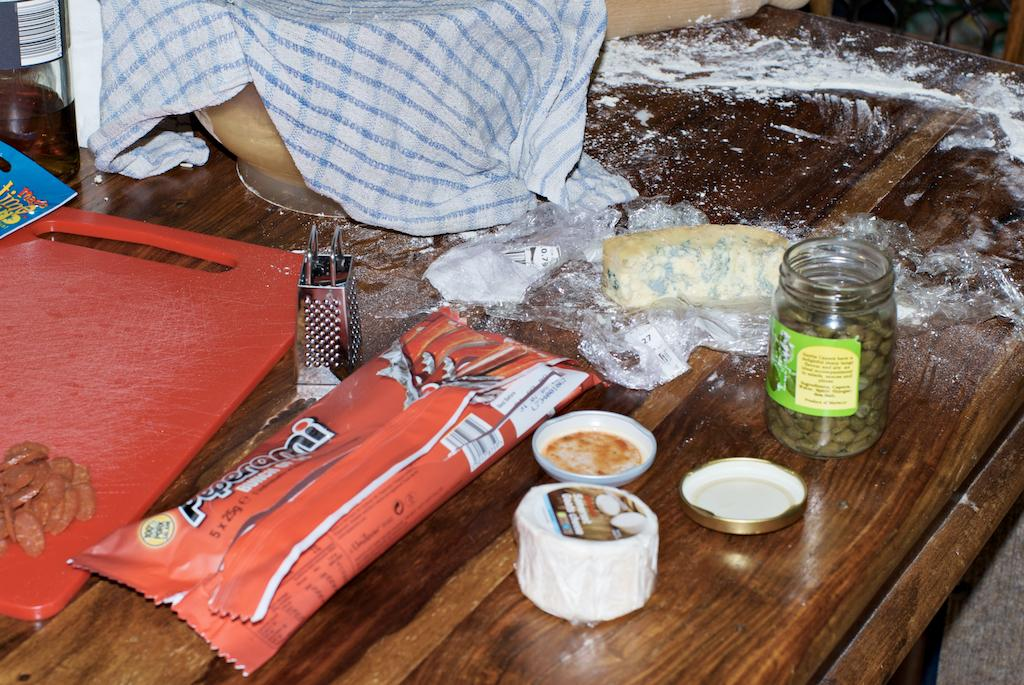What surface is visible in the image for cutting or preparing food? There is a chopping board in the image. What type of container is present in the image? There is a glass jar in the image. What food item can be seen in the image? There is butter in the image. What is the color of the table on which the objects are placed? The table is brown in color. What type of cloth is present in the image? There is a blue and white color cloth in the image. Where is the playground located in the image? There is no playground present in the image. What type of skin is visible on the butter in the image? Butter does not have skin; it is a dairy product. 